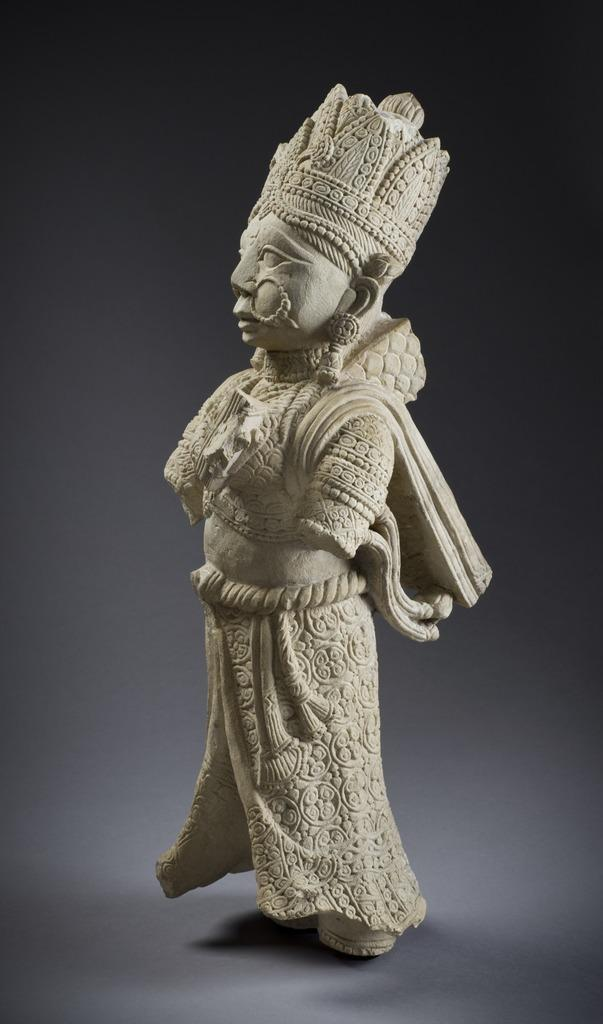What is the main subject of the image? There is a statue in the image. What can be seen on the statue? The statue has hands on it. Where is the chalk located in the image? There is no chalk present in the image. What type of face can be seen on the statue in the image? The provided facts do not mention a face on the statue, so it cannot be determined from the image. 